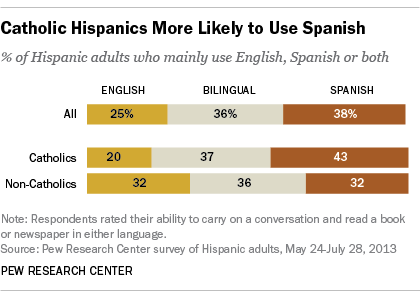Outline some significant characteristics in this image. The median value of all the leftmost bars is not greater than 50. The dark orange color bar represents a significant aspect of the overall data visualization. 